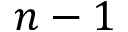Convert formula to latex. <formula><loc_0><loc_0><loc_500><loc_500>n - 1</formula> 